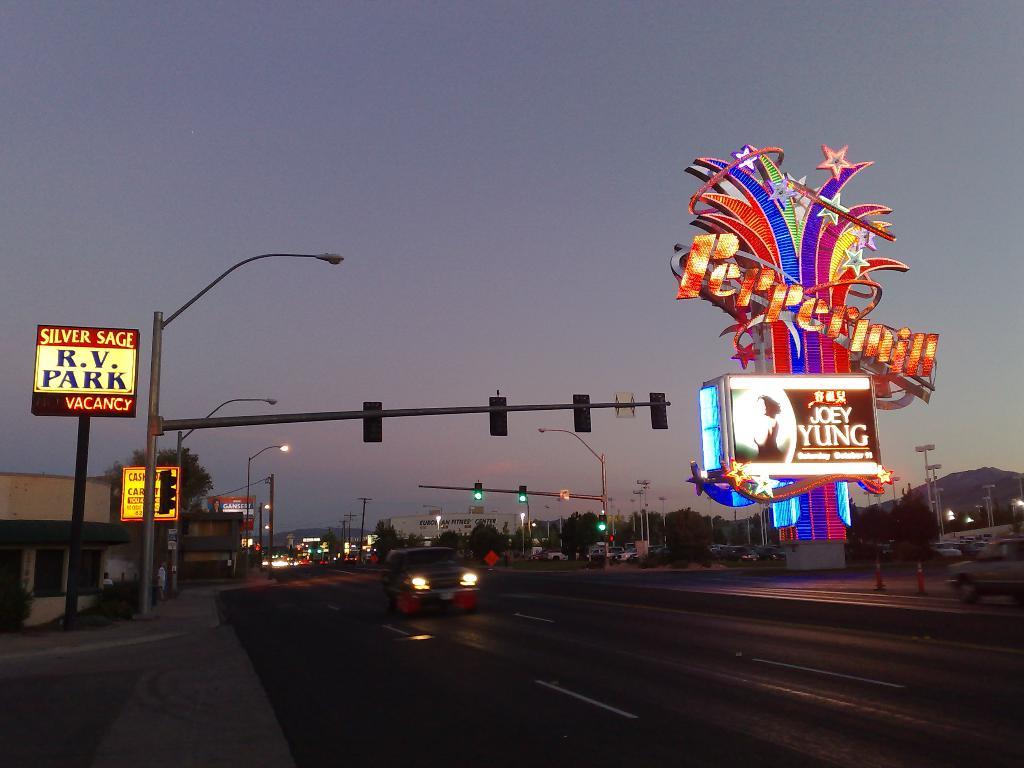What is the name of the rv park?
Ensure brevity in your answer.  Silver sage. 